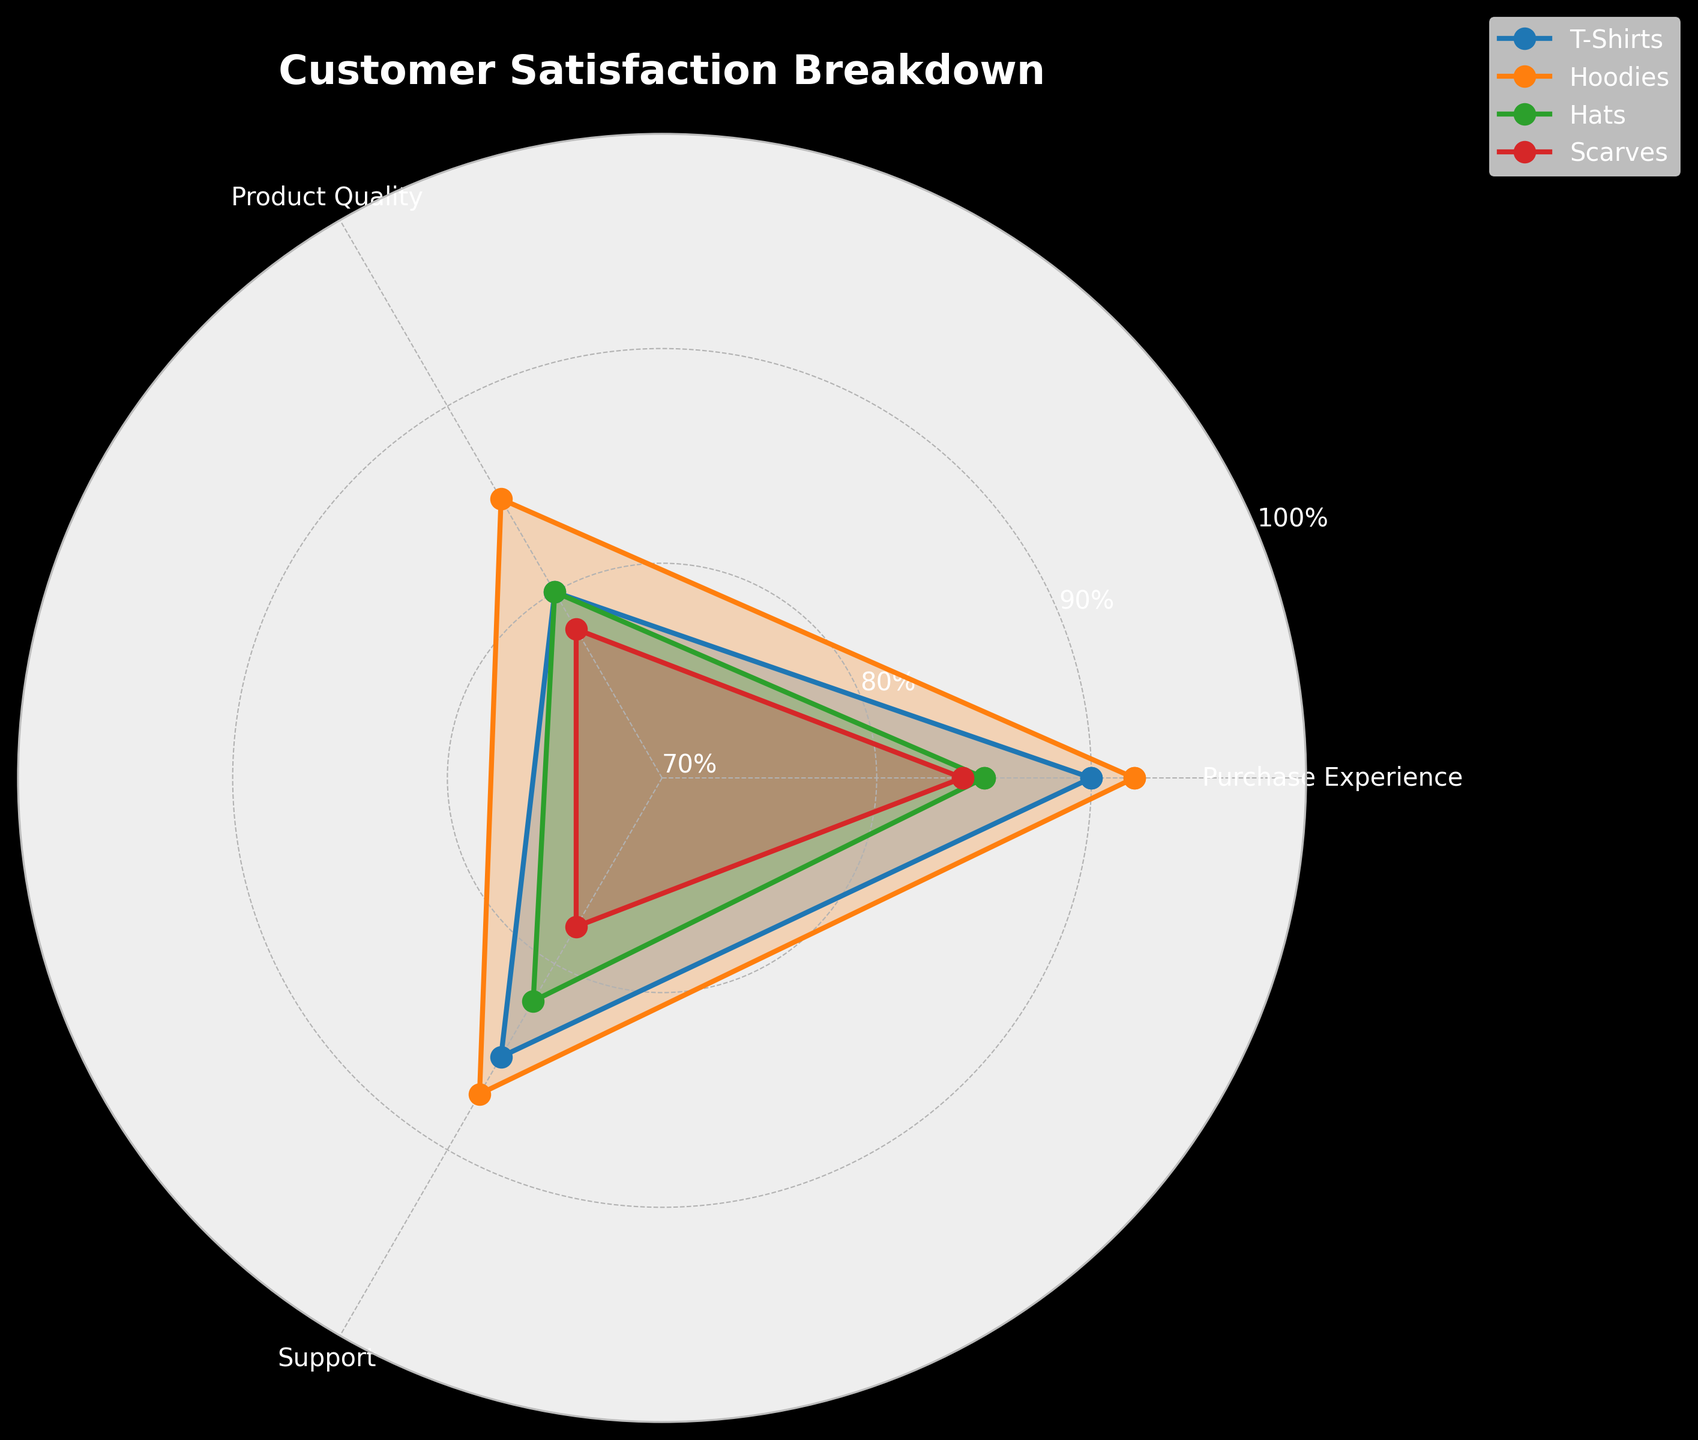What is the title of the figure? The title of the figure is located at the top and gives an overview of what the chart represents.
Answer: Customer Satisfaction Breakdown Which category has the highest purchase experience score? To determine the highest score, look at the 'Purchase Experience' axis and identify which line extends the farthest.
Answer: Hoodies What is the difference in support scores between T-Shirts and Hats? Find the support scores for T-Shirts (85) and Hats (82) on the 'Support' axis and subtract the latter from the former.
Answer: 3 Which category has the lowest overall product quality score? Examine the 'Product Quality' axis and identify the lowest point among the categories.
Answer: Scarves How many categories have a support score above 80? Check the 'Support' axis and count the categories with scores above 80.
Answer: 3 What is the average purchase experience score of all categories? Add the purchase experience scores for all categories (T-Shirts: 90, Hoodies: 92, Hats: 85, Scarves: 84), then divide by the number of categories (4).
Answer: 87.75 Which category shows the most balanced scores across all attributes? Observe the spread of scores for each category. The category with the least variation among Purchase Experience, Product Quality, and Support is the most balanced.
Answer: T-Shirts What is the combined product quality score of Hoodies and Scarves? Add the product quality scores for Hoodies (85) and Scarves (78).
Answer: 163 Which category has a higher total customer satisfaction score: Hats or Scarves? Compare the total customer satisfaction scores for Hats (82) and Scarves (80).
Answer: Hats What attribute has the highest score for the category with the highest overall customer satisfaction? Identify the category with the highest total customer satisfaction (Hoodies with 88), then find its highest attribute score.
Answer: Purchase Experience 